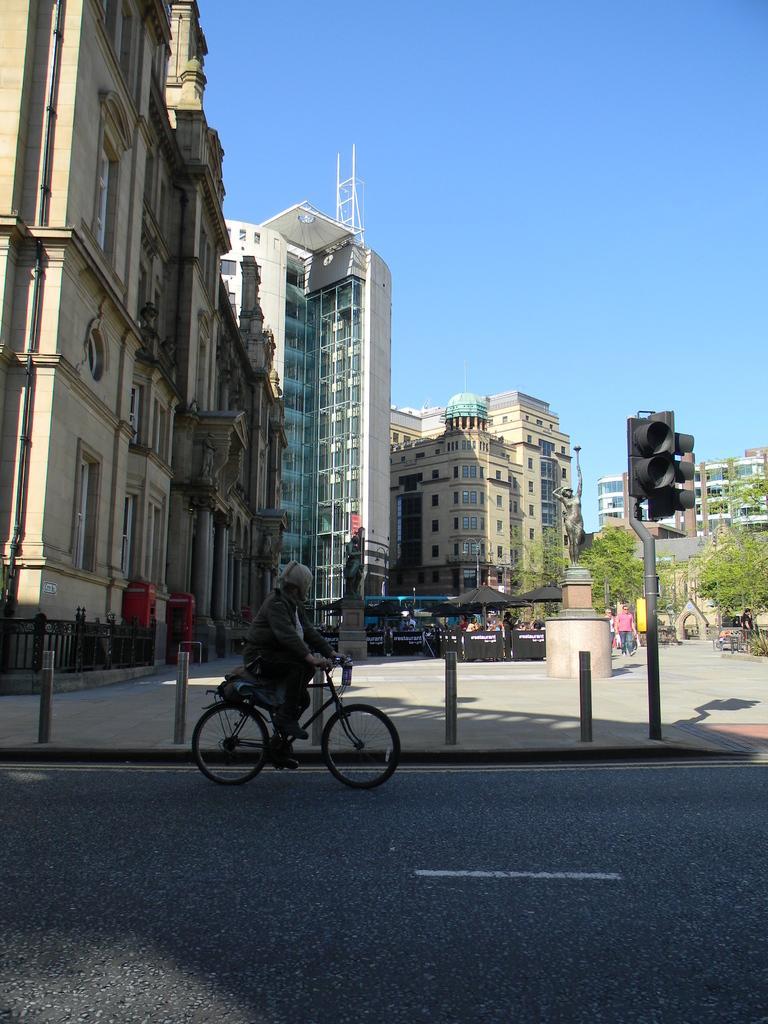Can you describe this image briefly? This image is clicked on the road. At the bottom, there is a road. In the front, we can see a person riding a bicycle. On the right, there is a man walking. In the background, there are many buildings. On the right, we can see a signal pole. At the top, there is sky. 